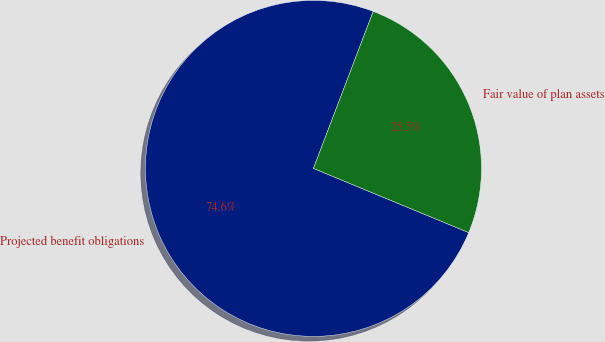Convert chart to OTSL. <chart><loc_0><loc_0><loc_500><loc_500><pie_chart><fcel>Projected benefit obligations<fcel>Fair value of plan assets<nl><fcel>74.55%<fcel>25.45%<nl></chart> 